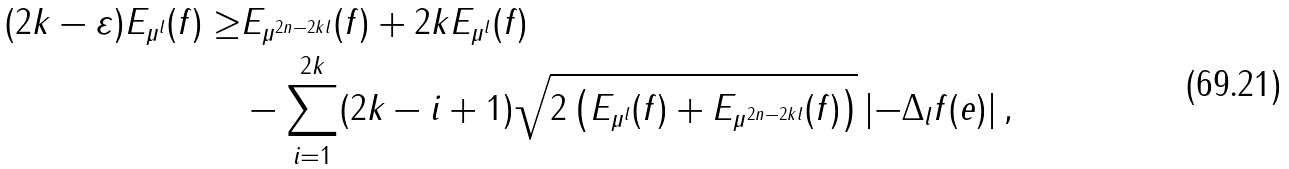Convert formula to latex. <formula><loc_0><loc_0><loc_500><loc_500>( 2 k - \varepsilon ) E _ { \mu ^ { l } } ( f ) \geq & E _ { \mu ^ { 2 n - 2 k l } } ( f ) + 2 k E _ { \mu ^ { l } } ( f ) \\ & - \sum _ { i = 1 } ^ { 2 k } ( 2 k - i + 1 ) \sqrt { 2 \left ( E _ { \mu ^ { l } } ( f ) + E _ { \mu ^ { 2 n - 2 k l } } ( f ) \right ) } \left | - \Delta _ { l } f ( e ) \right | ,</formula> 